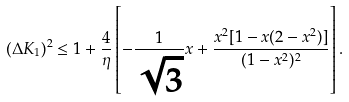Convert formula to latex. <formula><loc_0><loc_0><loc_500><loc_500>( \Delta K _ { 1 } ) ^ { 2 } \leq 1 + \frac { 4 } { \eta } \left [ - \frac { 1 } { \sqrt { 3 } } x + \frac { x ^ { 2 } [ 1 - x ( 2 - x ^ { 2 } ) ] } { ( 1 - x ^ { 2 } ) ^ { 2 } } \right ] .</formula> 